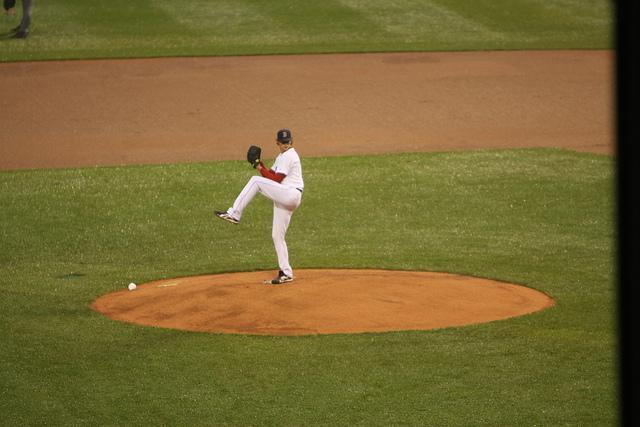How many athletes are pictured here?
Give a very brief answer. 1. How many drinks cups have straw?
Give a very brief answer. 0. 